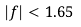<formula> <loc_0><loc_0><loc_500><loc_500>| f | < 1 . 6 5</formula> 